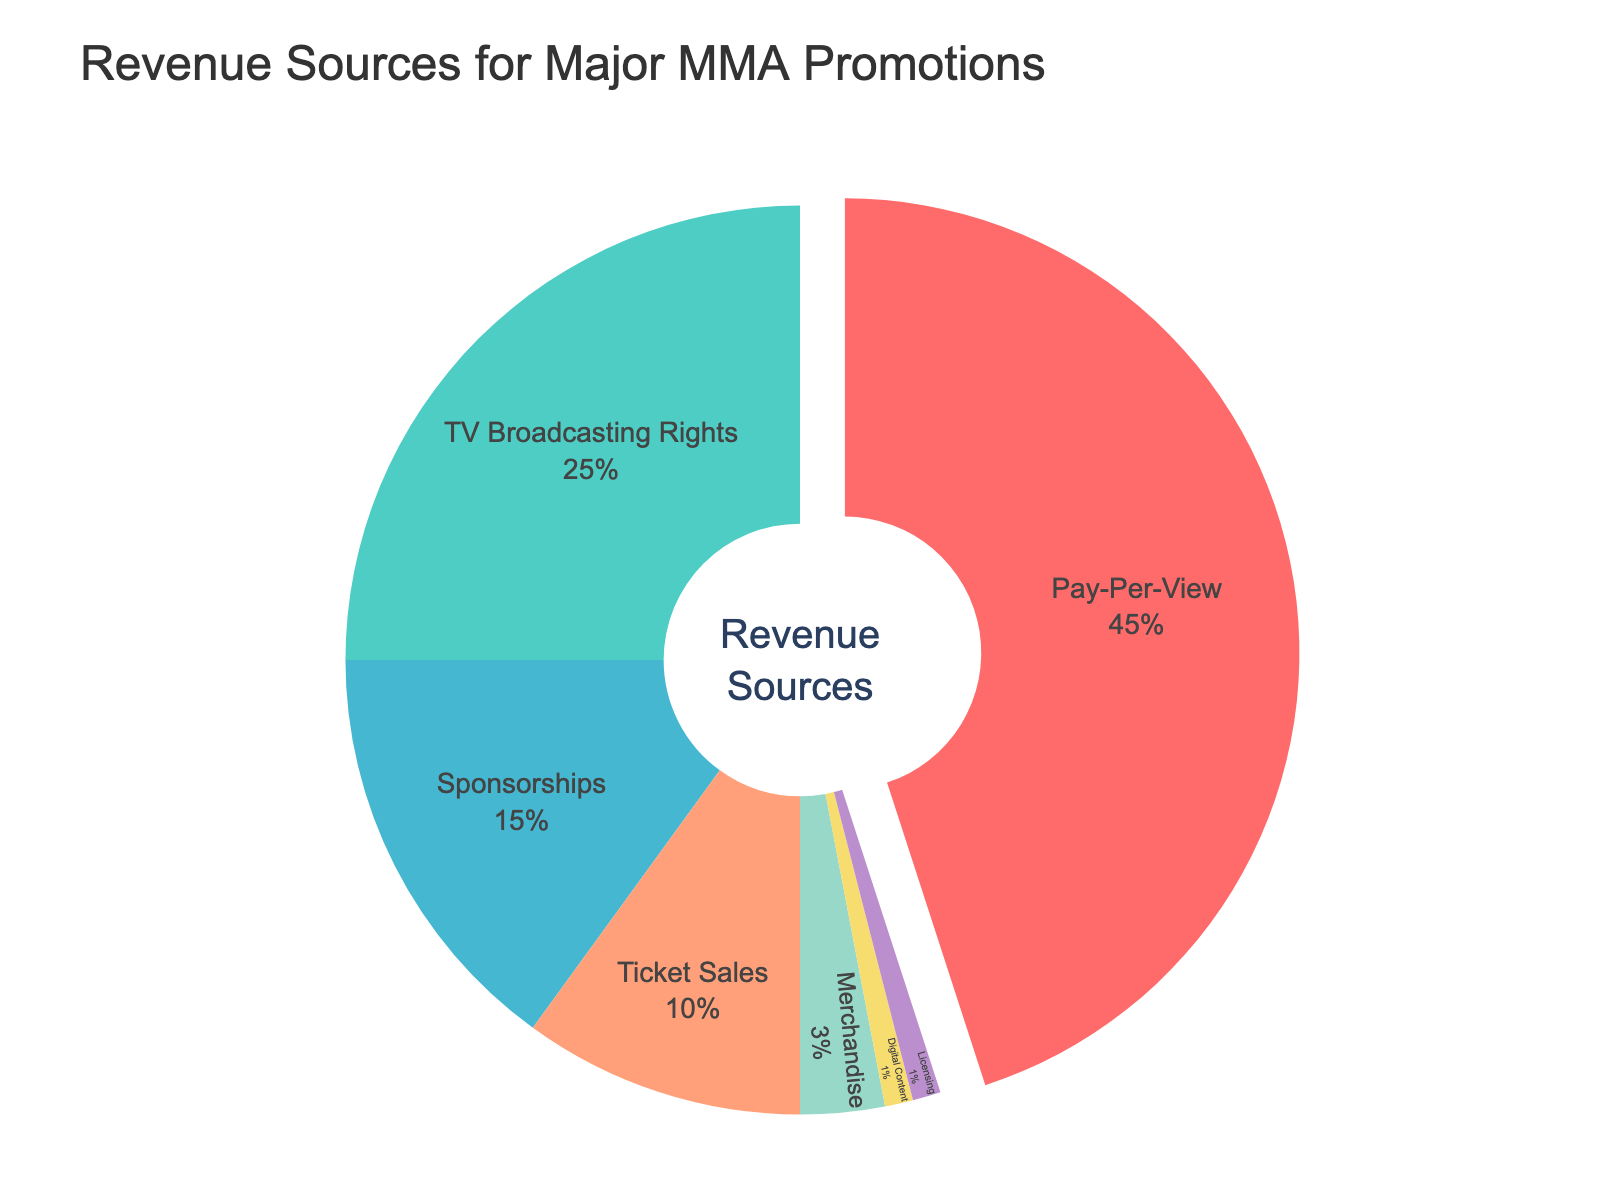Which category has the highest percentage of revenue? Pay-Per-View shows the highest percentage at 45%, it is represented by the largest segment of the pie chart labeled "45%" inside the segment.
Answer: Pay-Per-View Which two categories combined contribute the least to the overall revenue? The categories “Digital Content” and “Licensing” have the smallest percentages of 1% each. Summing them gives a total of 2%, indicating they together contribute least.
Answer: Digital Content and Licensing What is the percentage difference between TV Broadcasting Rights and Ticket Sales? TV Broadcasting Rights is 25% and Ticket Sales is 10%. The difference is calculated as 25% - 10% = 15%.
Answer: 15% Which categories together make up exactly half of the revenue? The categories Pay-Per-View (45%) and Sponsorships (15%) combined make up 60%, which is more than half. Therefore, no exact half possible by combining categories.
Answer: None If we merge Sponsorships and Merchandise into one, what percentage of total revenue do they represent? Sponsorships contribute 15% and Merchandise is 3%. By summing these, we get 15% + 3% = 18%.
Answer: 18% Out of the visualized categories, which one is represented with yellow color and what is its percentage? The yellow color represents the category "Ticket Sales" which has a percentage value of 10%.
Answer: Ticket Sales, 10% Which categories have a combined total above 70% of the total revenue? Pay-Per-View is 45% and TV Broadcasting Rights is 25%. Combined, they make 45% + 25% = 70%. Including any other category will exceed 70%. Therefore, Pay-Per-View and TV Broadcasting Rights alone add up to 70%.
Answer: Pay-Per-View and TV Broadcasting Rights What is the percentage of revenue from digital platforms, including both Digital Content and TV Broadcasting Rights? Digital Content is 1%, and TV Broadcasting Rights is 25%, summing these, 1% + 25% = 26%.
Answer: 26% How much more percentage-wise does Pay-Per-View generate compared to Merchandise? Pay-Per-View is 45% and Merchandise is 3%. Difference is 45% - 3% = 42%.
Answer: 42% What's the total percentage of revenue from categories excluding Pay-Per-View and TV Broadcasting Rights? Excluding Pay-Per-View (45%) and TV Broadcasting Rights (25%), remaining percentages are 15% (Sponsorships) + 10% (Ticket Sales) + 3% (Merchandise) + 1% (Digital Content) + 1% (Licensing) = 30%.
Answer: 30% 